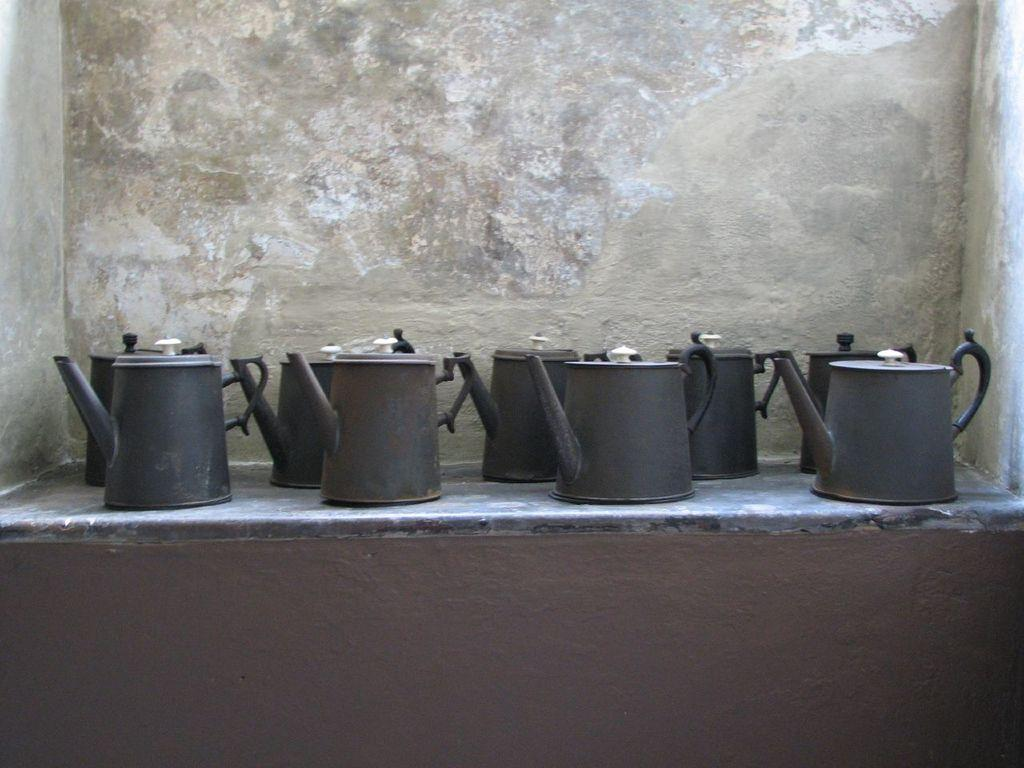What objects are present in the image? There is a group of kettles in the image. Where are the kettles located? The kettles are on a platform. What can be seen in the background of the image? There is a wall visible in the background of the image. What type of board is being used by the kettles in the image? There is no board present in the image; it features a group of kettles on a platform. Are any of the kettles wearing masks in the image? There are no masks present in the image; it features a group of kettles on a platform. 